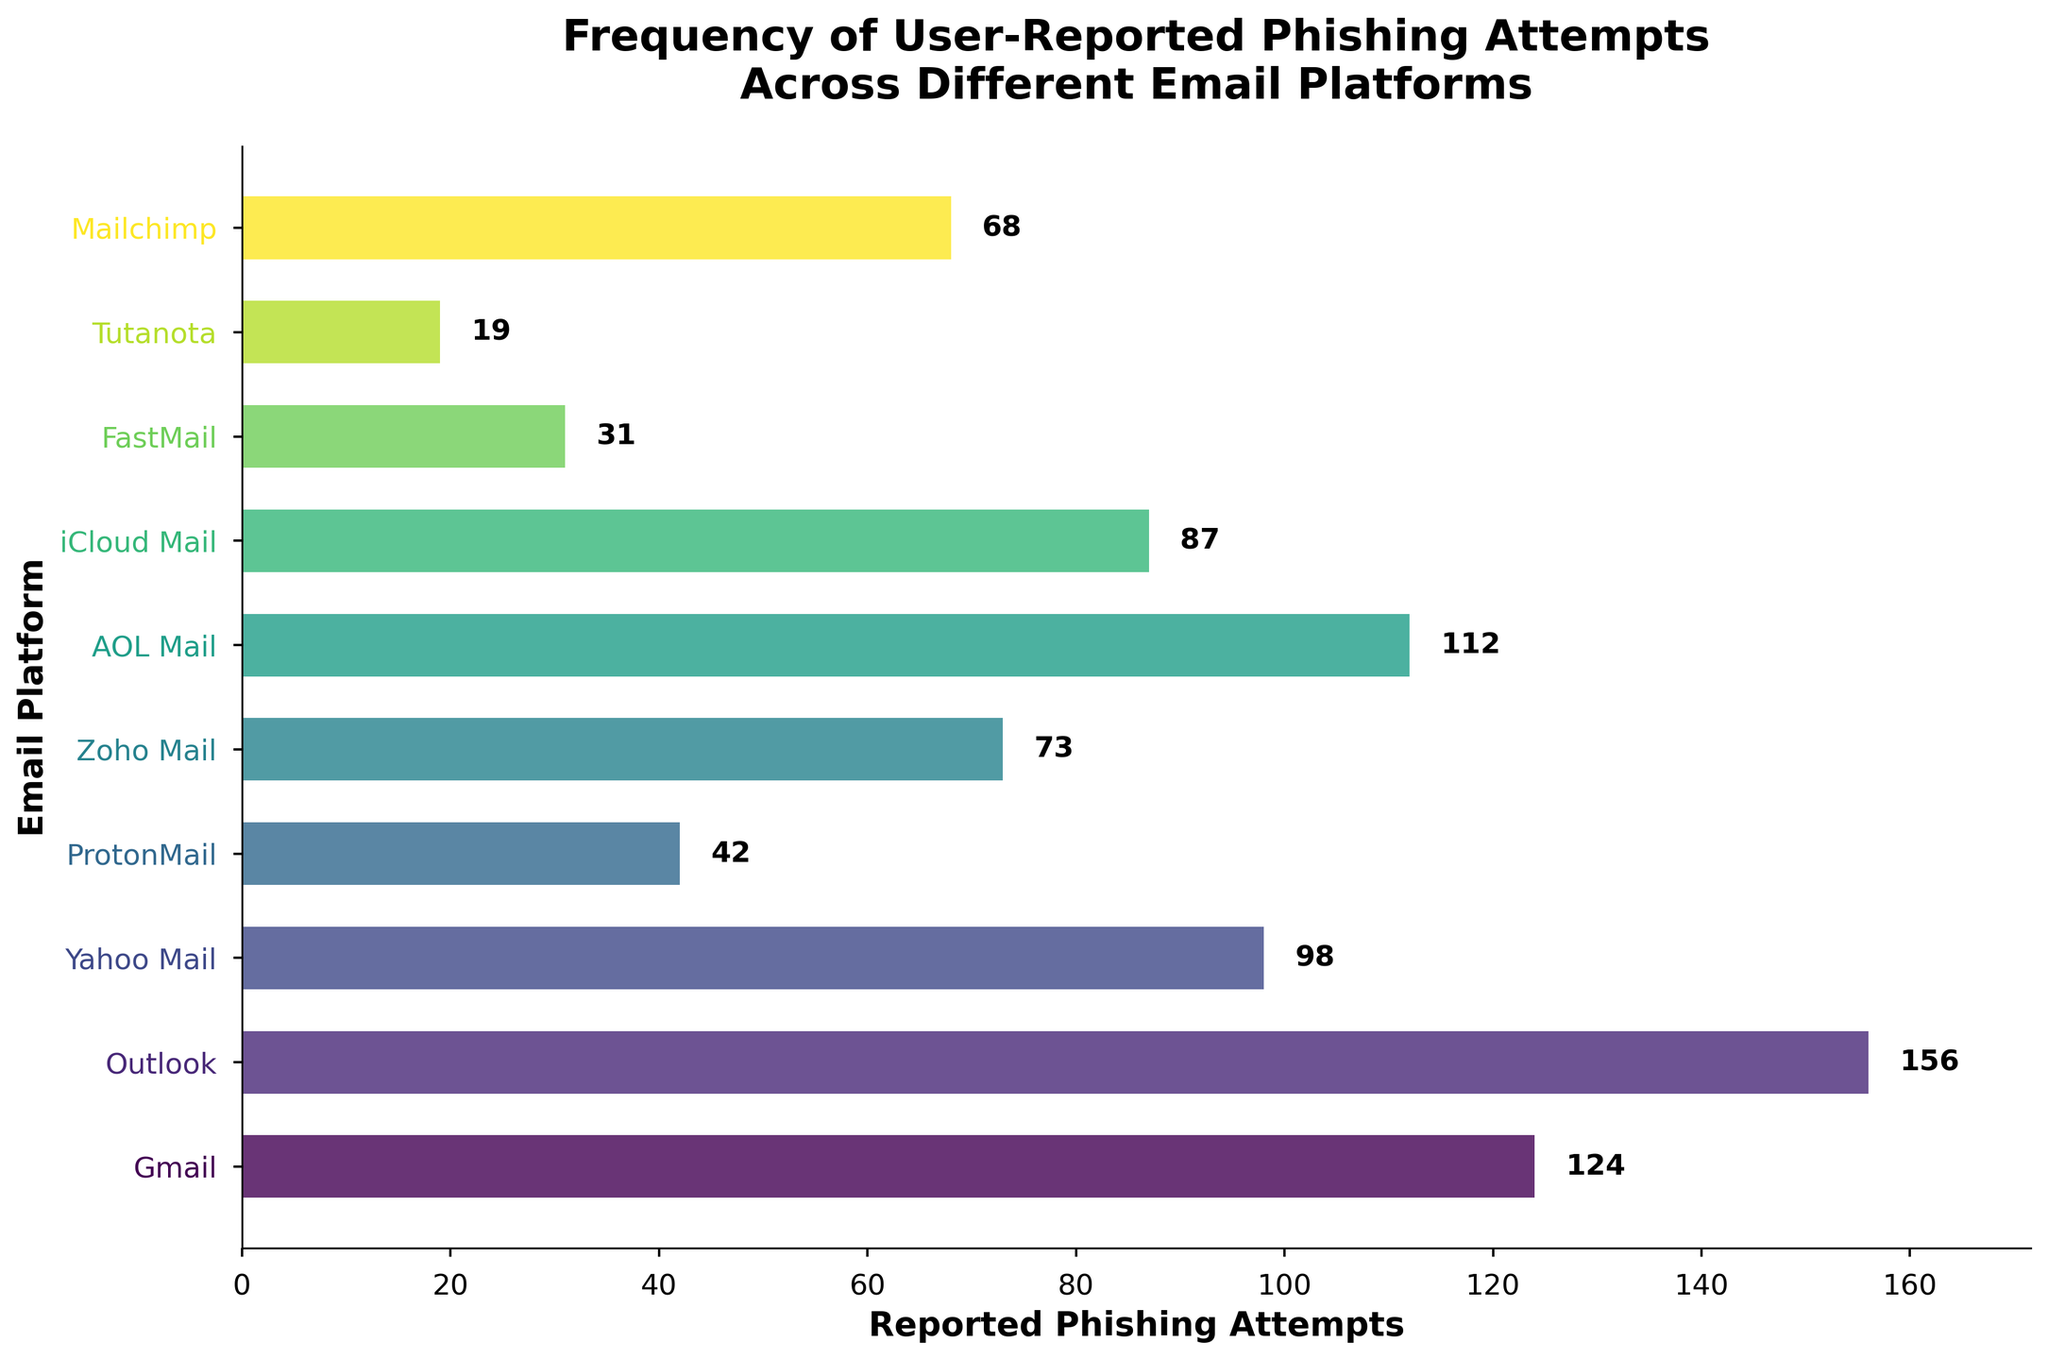What is the title of the plot? The title is usually placed at the top of the plot and describes the overall subject of the visual data.
Answer: Frequency of User-Reported Phishing Attempts Across Different Email Platforms Which email platform has the highest number of reported phishing attempts? To find the email platform with the highest value, look for the longest bar in the horizontal plot. The label next to this longest bar indicates the corresponding platform.
Answer: Outlook How many phishing attempts were reported for Yahoo Mail? Find the bar associated with Yahoo Mail, and read the number next to or above the bar.
Answer: 98 Which email platform is second lowest in phishing attempts? Order the platforms by the length of their bars and locate the second smallest one. Check the label next to this bar to identify the platform.
Answer: FastMail What is the total number of reported phishing attempts across all platforms? Add up the numbers for each platform: 124 + 156 + 98 + 42 + 73 + 112 + 87 + 31 + 19 + 68.
Answer: 810 What is the average number of reported phishing attempts per platform? Sum the values for all platforms and divide by the number of platforms: (124 + 156 + 98 + 42 + 73 + 112 + 87 + 31 + 19 + 68) / 10.
Answer: 81 What color is used for the bar representing Mailchimp? Find the bar that corresponds to Mailchimp and observe its color. The colors are represented in a gradient fashion from the colormap.
Answer: A shade within the viridis colormap (color gradient) 